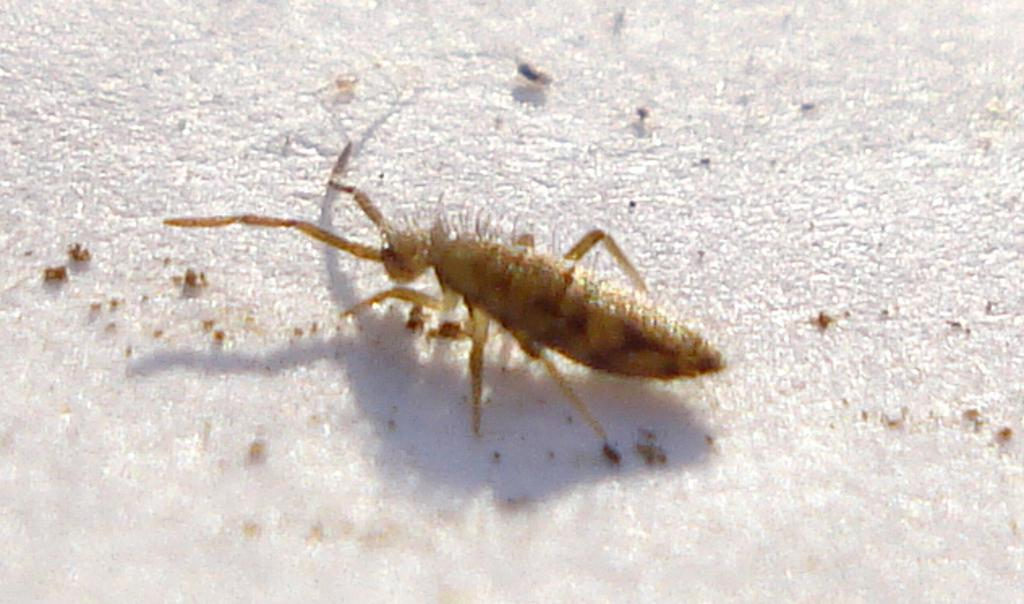What is present in the image that is small and possibly insect-like? There is a bug in the image. What is the bug situated on? The bug is on an object. What type of test is being conducted on the island with the cabbage in the image? There is no test, island, or cabbage present in the image; it only features a bug on an object. 